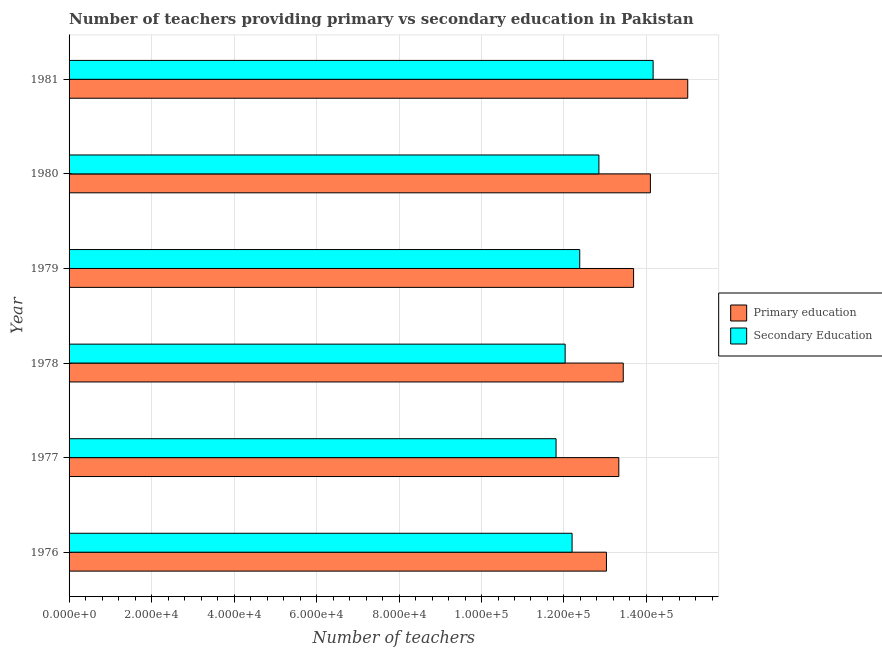How many different coloured bars are there?
Provide a succinct answer. 2. How many bars are there on the 3rd tick from the top?
Your response must be concise. 2. What is the label of the 6th group of bars from the top?
Your answer should be very brief. 1976. What is the number of secondary teachers in 1979?
Offer a very short reply. 1.24e+05. Across all years, what is the maximum number of secondary teachers?
Provide a succinct answer. 1.42e+05. Across all years, what is the minimum number of secondary teachers?
Your answer should be very brief. 1.18e+05. In which year was the number of primary teachers maximum?
Ensure brevity in your answer.  1981. In which year was the number of secondary teachers minimum?
Keep it short and to the point. 1977. What is the total number of primary teachers in the graph?
Offer a very short reply. 8.26e+05. What is the difference between the number of secondary teachers in 1976 and that in 1981?
Ensure brevity in your answer.  -1.97e+04. What is the difference between the number of primary teachers in 1976 and the number of secondary teachers in 1978?
Provide a succinct answer. 1.00e+04. What is the average number of secondary teachers per year?
Make the answer very short. 1.26e+05. In the year 1981, what is the difference between the number of secondary teachers and number of primary teachers?
Offer a very short reply. -8391. What is the ratio of the number of primary teachers in 1977 to that in 1980?
Offer a terse response. 0.95. Is the number of primary teachers in 1977 less than that in 1981?
Give a very brief answer. Yes. What is the difference between the highest and the second highest number of secondary teachers?
Make the answer very short. 1.31e+04. What is the difference between the highest and the lowest number of primary teachers?
Your answer should be very brief. 1.97e+04. In how many years, is the number of secondary teachers greater than the average number of secondary teachers taken over all years?
Your answer should be very brief. 2. Is the sum of the number of primary teachers in 1977 and 1978 greater than the maximum number of secondary teachers across all years?
Give a very brief answer. Yes. What does the 2nd bar from the bottom in 1981 represents?
Ensure brevity in your answer.  Secondary Education. Are the values on the major ticks of X-axis written in scientific E-notation?
Your response must be concise. Yes. Does the graph contain any zero values?
Your response must be concise. No. Does the graph contain grids?
Ensure brevity in your answer.  Yes. What is the title of the graph?
Your answer should be compact. Number of teachers providing primary vs secondary education in Pakistan. What is the label or title of the X-axis?
Offer a very short reply. Number of teachers. What is the label or title of the Y-axis?
Make the answer very short. Year. What is the Number of teachers of Primary education in 1976?
Offer a very short reply. 1.30e+05. What is the Number of teachers of Secondary Education in 1976?
Provide a short and direct response. 1.22e+05. What is the Number of teachers of Primary education in 1977?
Your response must be concise. 1.33e+05. What is the Number of teachers of Secondary Education in 1977?
Give a very brief answer. 1.18e+05. What is the Number of teachers in Primary education in 1978?
Give a very brief answer. 1.34e+05. What is the Number of teachers in Secondary Education in 1978?
Provide a short and direct response. 1.20e+05. What is the Number of teachers of Primary education in 1979?
Your answer should be very brief. 1.37e+05. What is the Number of teachers in Secondary Education in 1979?
Keep it short and to the point. 1.24e+05. What is the Number of teachers of Primary education in 1980?
Give a very brief answer. 1.41e+05. What is the Number of teachers in Secondary Education in 1980?
Your answer should be compact. 1.28e+05. What is the Number of teachers in Primary education in 1981?
Provide a short and direct response. 1.50e+05. What is the Number of teachers in Secondary Education in 1981?
Ensure brevity in your answer.  1.42e+05. Across all years, what is the maximum Number of teachers in Primary education?
Make the answer very short. 1.50e+05. Across all years, what is the maximum Number of teachers of Secondary Education?
Offer a very short reply. 1.42e+05. Across all years, what is the minimum Number of teachers of Primary education?
Offer a very short reply. 1.30e+05. Across all years, what is the minimum Number of teachers in Secondary Education?
Offer a very short reply. 1.18e+05. What is the total Number of teachers of Primary education in the graph?
Give a very brief answer. 8.26e+05. What is the total Number of teachers of Secondary Education in the graph?
Provide a short and direct response. 7.54e+05. What is the difference between the Number of teachers of Primary education in 1976 and that in 1977?
Your answer should be compact. -3000. What is the difference between the Number of teachers in Secondary Education in 1976 and that in 1977?
Ensure brevity in your answer.  3885. What is the difference between the Number of teachers of Primary education in 1976 and that in 1978?
Your answer should be very brief. -4075. What is the difference between the Number of teachers in Secondary Education in 1976 and that in 1978?
Your response must be concise. 1681. What is the difference between the Number of teachers in Primary education in 1976 and that in 1979?
Offer a terse response. -6581. What is the difference between the Number of teachers in Secondary Education in 1976 and that in 1979?
Your answer should be very brief. -1855. What is the difference between the Number of teachers of Primary education in 1976 and that in 1980?
Your answer should be very brief. -1.07e+04. What is the difference between the Number of teachers in Secondary Education in 1976 and that in 1980?
Your response must be concise. -6505. What is the difference between the Number of teachers in Primary education in 1976 and that in 1981?
Your answer should be compact. -1.97e+04. What is the difference between the Number of teachers of Secondary Education in 1976 and that in 1981?
Your answer should be very brief. -1.97e+04. What is the difference between the Number of teachers in Primary education in 1977 and that in 1978?
Keep it short and to the point. -1075. What is the difference between the Number of teachers in Secondary Education in 1977 and that in 1978?
Give a very brief answer. -2204. What is the difference between the Number of teachers in Primary education in 1977 and that in 1979?
Make the answer very short. -3581. What is the difference between the Number of teachers of Secondary Education in 1977 and that in 1979?
Your response must be concise. -5740. What is the difference between the Number of teachers in Primary education in 1977 and that in 1980?
Your answer should be compact. -7654. What is the difference between the Number of teachers of Secondary Education in 1977 and that in 1980?
Your response must be concise. -1.04e+04. What is the difference between the Number of teachers in Primary education in 1977 and that in 1981?
Your answer should be very brief. -1.67e+04. What is the difference between the Number of teachers of Secondary Education in 1977 and that in 1981?
Your response must be concise. -2.35e+04. What is the difference between the Number of teachers of Primary education in 1978 and that in 1979?
Ensure brevity in your answer.  -2506. What is the difference between the Number of teachers of Secondary Education in 1978 and that in 1979?
Make the answer very short. -3536. What is the difference between the Number of teachers in Primary education in 1978 and that in 1980?
Offer a terse response. -6579. What is the difference between the Number of teachers of Secondary Education in 1978 and that in 1980?
Your answer should be very brief. -8186. What is the difference between the Number of teachers in Primary education in 1978 and that in 1981?
Give a very brief answer. -1.56e+04. What is the difference between the Number of teachers in Secondary Education in 1978 and that in 1981?
Offer a very short reply. -2.13e+04. What is the difference between the Number of teachers of Primary education in 1979 and that in 1980?
Your answer should be very brief. -4073. What is the difference between the Number of teachers in Secondary Education in 1979 and that in 1980?
Keep it short and to the point. -4650. What is the difference between the Number of teachers of Primary education in 1979 and that in 1981?
Offer a terse response. -1.31e+04. What is the difference between the Number of teachers of Secondary Education in 1979 and that in 1981?
Keep it short and to the point. -1.78e+04. What is the difference between the Number of teachers in Primary education in 1980 and that in 1981?
Your answer should be compact. -9055. What is the difference between the Number of teachers of Secondary Education in 1980 and that in 1981?
Offer a terse response. -1.31e+04. What is the difference between the Number of teachers of Primary education in 1976 and the Number of teachers of Secondary Education in 1977?
Keep it short and to the point. 1.22e+04. What is the difference between the Number of teachers of Primary education in 1976 and the Number of teachers of Secondary Education in 1978?
Provide a short and direct response. 1.00e+04. What is the difference between the Number of teachers of Primary education in 1976 and the Number of teachers of Secondary Education in 1979?
Ensure brevity in your answer.  6478. What is the difference between the Number of teachers in Primary education in 1976 and the Number of teachers in Secondary Education in 1980?
Keep it short and to the point. 1828. What is the difference between the Number of teachers in Primary education in 1976 and the Number of teachers in Secondary Education in 1981?
Provide a short and direct response. -1.13e+04. What is the difference between the Number of teachers of Primary education in 1977 and the Number of teachers of Secondary Education in 1978?
Keep it short and to the point. 1.30e+04. What is the difference between the Number of teachers of Primary education in 1977 and the Number of teachers of Secondary Education in 1979?
Offer a terse response. 9478. What is the difference between the Number of teachers of Primary education in 1977 and the Number of teachers of Secondary Education in 1980?
Offer a very short reply. 4828. What is the difference between the Number of teachers of Primary education in 1977 and the Number of teachers of Secondary Education in 1981?
Give a very brief answer. -8318. What is the difference between the Number of teachers in Primary education in 1978 and the Number of teachers in Secondary Education in 1979?
Offer a terse response. 1.06e+04. What is the difference between the Number of teachers of Primary education in 1978 and the Number of teachers of Secondary Education in 1980?
Give a very brief answer. 5903. What is the difference between the Number of teachers in Primary education in 1978 and the Number of teachers in Secondary Education in 1981?
Keep it short and to the point. -7243. What is the difference between the Number of teachers in Primary education in 1979 and the Number of teachers in Secondary Education in 1980?
Keep it short and to the point. 8409. What is the difference between the Number of teachers in Primary education in 1979 and the Number of teachers in Secondary Education in 1981?
Provide a succinct answer. -4737. What is the difference between the Number of teachers of Primary education in 1980 and the Number of teachers of Secondary Education in 1981?
Keep it short and to the point. -664. What is the average Number of teachers in Primary education per year?
Provide a short and direct response. 1.38e+05. What is the average Number of teachers of Secondary Education per year?
Offer a terse response. 1.26e+05. In the year 1976, what is the difference between the Number of teachers of Primary education and Number of teachers of Secondary Education?
Your response must be concise. 8333. In the year 1977, what is the difference between the Number of teachers of Primary education and Number of teachers of Secondary Education?
Make the answer very short. 1.52e+04. In the year 1978, what is the difference between the Number of teachers of Primary education and Number of teachers of Secondary Education?
Make the answer very short. 1.41e+04. In the year 1979, what is the difference between the Number of teachers in Primary education and Number of teachers in Secondary Education?
Offer a very short reply. 1.31e+04. In the year 1980, what is the difference between the Number of teachers of Primary education and Number of teachers of Secondary Education?
Offer a terse response. 1.25e+04. In the year 1981, what is the difference between the Number of teachers in Primary education and Number of teachers in Secondary Education?
Offer a terse response. 8391. What is the ratio of the Number of teachers in Primary education in 1976 to that in 1977?
Give a very brief answer. 0.98. What is the ratio of the Number of teachers of Secondary Education in 1976 to that in 1977?
Give a very brief answer. 1.03. What is the ratio of the Number of teachers in Primary education in 1976 to that in 1978?
Offer a terse response. 0.97. What is the ratio of the Number of teachers in Primary education in 1976 to that in 1979?
Your answer should be very brief. 0.95. What is the ratio of the Number of teachers in Secondary Education in 1976 to that in 1979?
Keep it short and to the point. 0.98. What is the ratio of the Number of teachers of Primary education in 1976 to that in 1980?
Your answer should be compact. 0.92. What is the ratio of the Number of teachers in Secondary Education in 1976 to that in 1980?
Provide a succinct answer. 0.95. What is the ratio of the Number of teachers of Primary education in 1976 to that in 1981?
Keep it short and to the point. 0.87. What is the ratio of the Number of teachers of Secondary Education in 1976 to that in 1981?
Your response must be concise. 0.86. What is the ratio of the Number of teachers in Primary education in 1977 to that in 1978?
Offer a very short reply. 0.99. What is the ratio of the Number of teachers in Secondary Education in 1977 to that in 1978?
Your answer should be compact. 0.98. What is the ratio of the Number of teachers of Primary education in 1977 to that in 1979?
Your answer should be very brief. 0.97. What is the ratio of the Number of teachers in Secondary Education in 1977 to that in 1979?
Keep it short and to the point. 0.95. What is the ratio of the Number of teachers in Primary education in 1977 to that in 1980?
Your answer should be compact. 0.95. What is the ratio of the Number of teachers in Secondary Education in 1977 to that in 1980?
Your answer should be compact. 0.92. What is the ratio of the Number of teachers of Primary education in 1977 to that in 1981?
Your answer should be compact. 0.89. What is the ratio of the Number of teachers of Secondary Education in 1977 to that in 1981?
Provide a short and direct response. 0.83. What is the ratio of the Number of teachers in Primary education in 1978 to that in 1979?
Provide a short and direct response. 0.98. What is the ratio of the Number of teachers of Secondary Education in 1978 to that in 1979?
Ensure brevity in your answer.  0.97. What is the ratio of the Number of teachers in Primary education in 1978 to that in 1980?
Keep it short and to the point. 0.95. What is the ratio of the Number of teachers of Secondary Education in 1978 to that in 1980?
Your answer should be very brief. 0.94. What is the ratio of the Number of teachers of Primary education in 1978 to that in 1981?
Your response must be concise. 0.9. What is the ratio of the Number of teachers in Secondary Education in 1978 to that in 1981?
Your answer should be very brief. 0.85. What is the ratio of the Number of teachers in Primary education in 1979 to that in 1980?
Offer a very short reply. 0.97. What is the ratio of the Number of teachers in Secondary Education in 1979 to that in 1980?
Offer a terse response. 0.96. What is the ratio of the Number of teachers of Primary education in 1979 to that in 1981?
Your response must be concise. 0.91. What is the ratio of the Number of teachers in Secondary Education in 1979 to that in 1981?
Ensure brevity in your answer.  0.87. What is the ratio of the Number of teachers of Primary education in 1980 to that in 1981?
Make the answer very short. 0.94. What is the ratio of the Number of teachers in Secondary Education in 1980 to that in 1981?
Your response must be concise. 0.91. What is the difference between the highest and the second highest Number of teachers of Primary education?
Your answer should be compact. 9055. What is the difference between the highest and the second highest Number of teachers of Secondary Education?
Offer a terse response. 1.31e+04. What is the difference between the highest and the lowest Number of teachers in Primary education?
Keep it short and to the point. 1.97e+04. What is the difference between the highest and the lowest Number of teachers of Secondary Education?
Your response must be concise. 2.35e+04. 